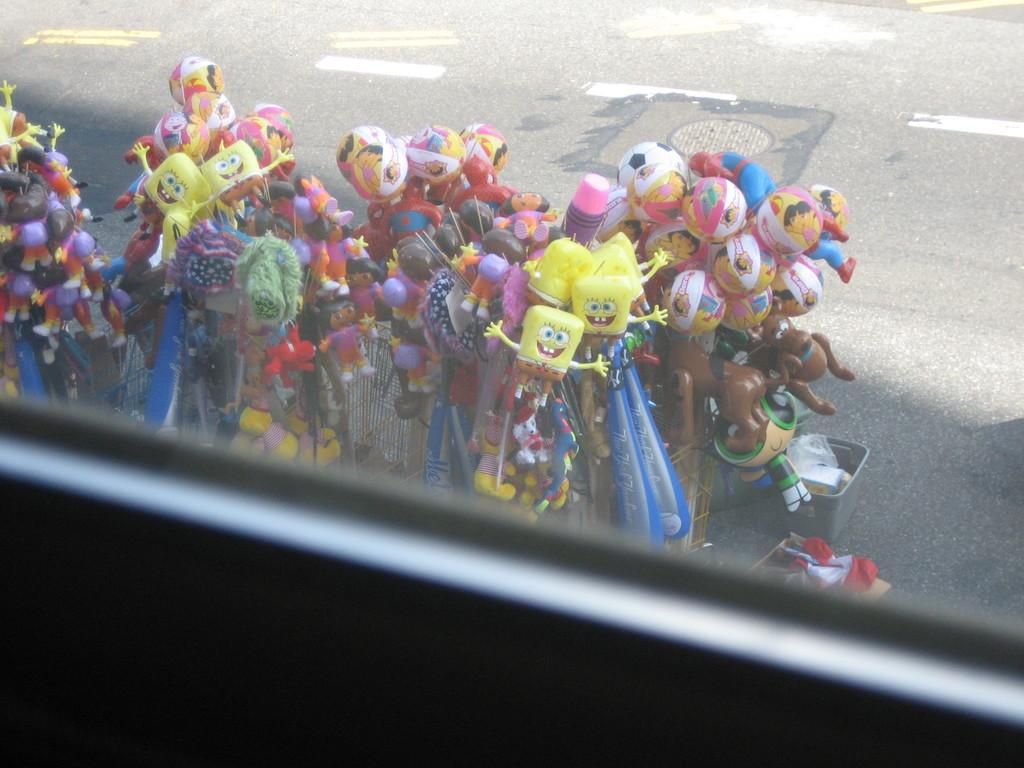What object is present in the image that is typically used for drinking? There is a glass in the image. What are the dolls doing in the image? The dolls are on the road in the image. How can the dolls be seen in the image? The dolls are visible through the glass in the image. What type of alley can be seen in the image? There is no alley present in the image. Is there a bridge visible in the image? There is no bridge present in the image. 